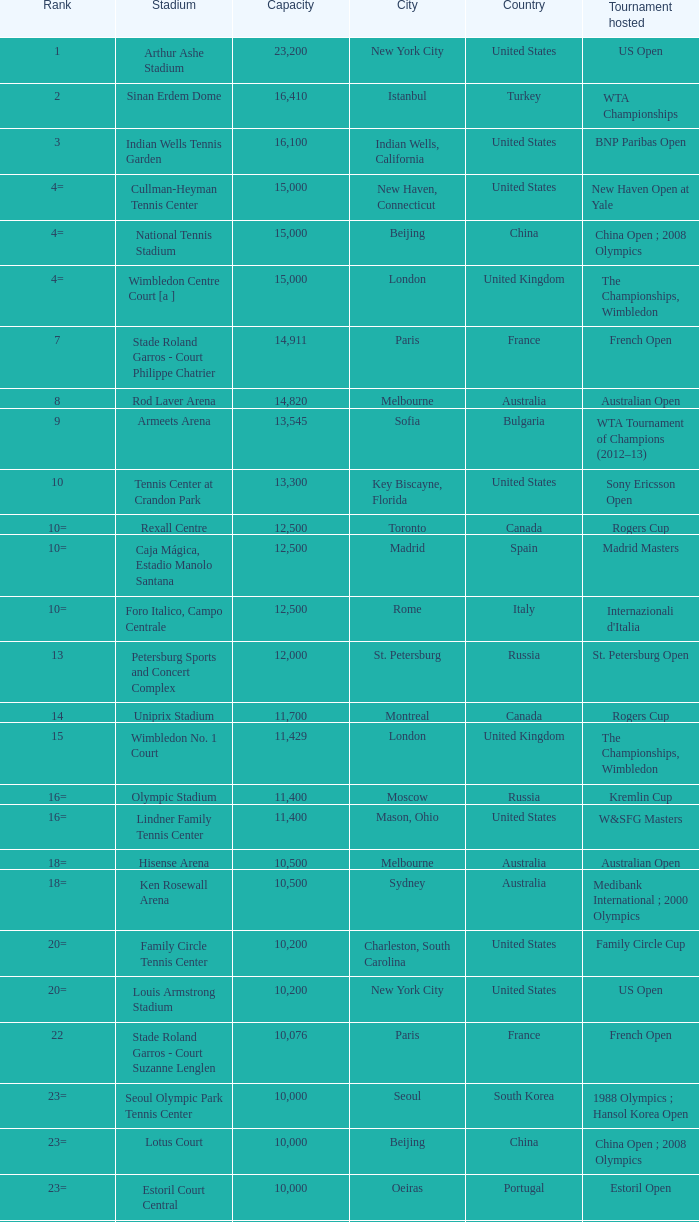What country has grandstand stadium as the stadium? United States. 